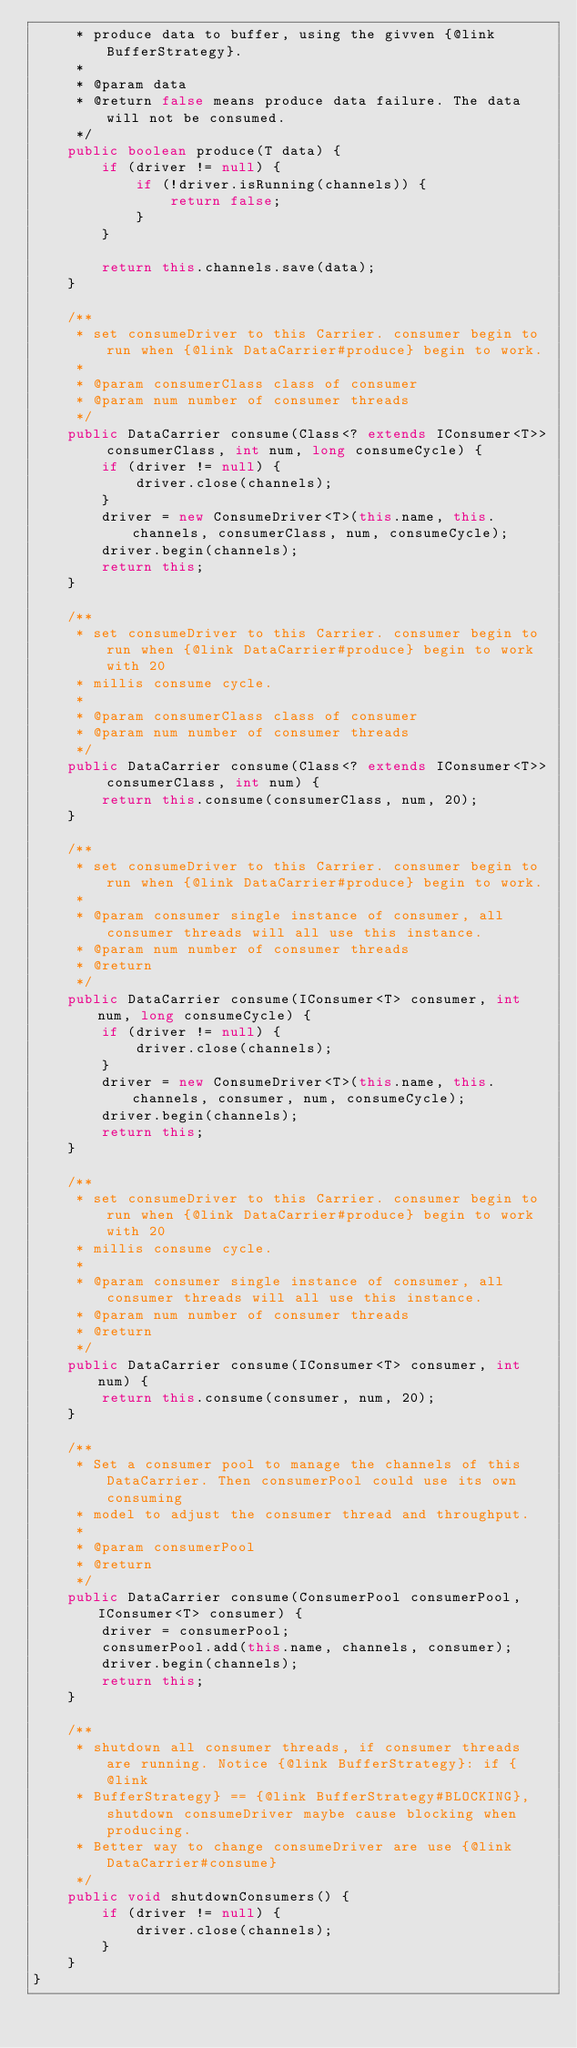Convert code to text. <code><loc_0><loc_0><loc_500><loc_500><_Java_>     * produce data to buffer, using the givven {@link BufferStrategy}.
     *
     * @param data
     * @return false means produce data failure. The data will not be consumed.
     */
    public boolean produce(T data) {
        if (driver != null) {
            if (!driver.isRunning(channels)) {
                return false;
            }
        }

        return this.channels.save(data);
    }

    /**
     * set consumeDriver to this Carrier. consumer begin to run when {@link DataCarrier#produce} begin to work.
     *
     * @param consumerClass class of consumer
     * @param num number of consumer threads
     */
    public DataCarrier consume(Class<? extends IConsumer<T>> consumerClass, int num, long consumeCycle) {
        if (driver != null) {
            driver.close(channels);
        }
        driver = new ConsumeDriver<T>(this.name, this.channels, consumerClass, num, consumeCycle);
        driver.begin(channels);
        return this;
    }

    /**
     * set consumeDriver to this Carrier. consumer begin to run when {@link DataCarrier#produce} begin to work with 20
     * millis consume cycle.
     *
     * @param consumerClass class of consumer
     * @param num number of consumer threads
     */
    public DataCarrier consume(Class<? extends IConsumer<T>> consumerClass, int num) {
        return this.consume(consumerClass, num, 20);
    }

    /**
     * set consumeDriver to this Carrier. consumer begin to run when {@link DataCarrier#produce} begin to work.
     *
     * @param consumer single instance of consumer, all consumer threads will all use this instance.
     * @param num number of consumer threads
     * @return
     */
    public DataCarrier consume(IConsumer<T> consumer, int num, long consumeCycle) {
        if (driver != null) {
            driver.close(channels);
        }
        driver = new ConsumeDriver<T>(this.name, this.channels, consumer, num, consumeCycle);
        driver.begin(channels);
        return this;
    }

    /**
     * set consumeDriver to this Carrier. consumer begin to run when {@link DataCarrier#produce} begin to work with 20
     * millis consume cycle.
     *
     * @param consumer single instance of consumer, all consumer threads will all use this instance.
     * @param num number of consumer threads
     * @return
     */
    public DataCarrier consume(IConsumer<T> consumer, int num) {
        return this.consume(consumer, num, 20);
    }

    /**
     * Set a consumer pool to manage the channels of this DataCarrier. Then consumerPool could use its own consuming
     * model to adjust the consumer thread and throughput.
     *
     * @param consumerPool
     * @return
     */
    public DataCarrier consume(ConsumerPool consumerPool, IConsumer<T> consumer) {
        driver = consumerPool;
        consumerPool.add(this.name, channels, consumer);
        driver.begin(channels);
        return this;
    }

    /**
     * shutdown all consumer threads, if consumer threads are running. Notice {@link BufferStrategy}: if {@link
     * BufferStrategy} == {@link BufferStrategy#BLOCKING}, shutdown consumeDriver maybe cause blocking when producing.
     * Better way to change consumeDriver are use {@link DataCarrier#consume}
     */
    public void shutdownConsumers() {
        if (driver != null) {
            driver.close(channels);
        }
    }
}
</code> 